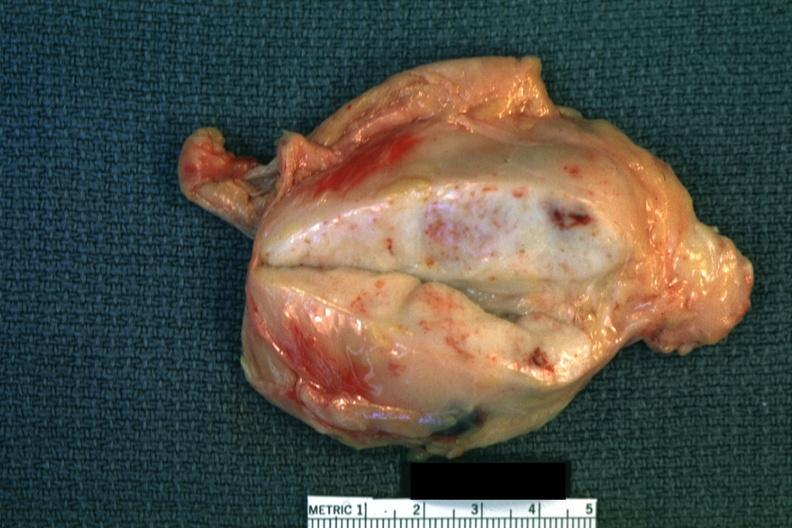how does close-up enlarge white node?
Answer the question using a single word or phrase. Focal necrosis quite good 